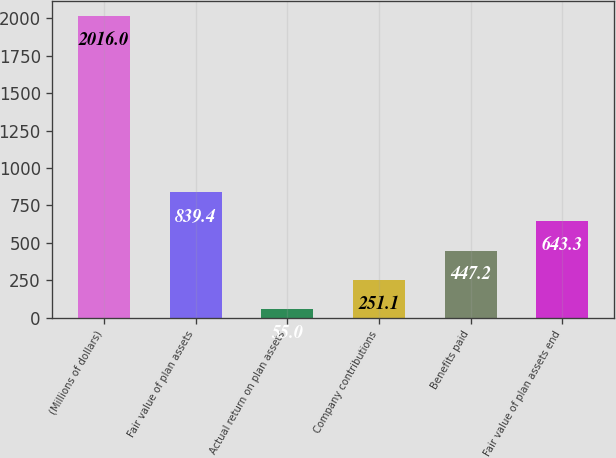Convert chart to OTSL. <chart><loc_0><loc_0><loc_500><loc_500><bar_chart><fcel>(Millions of dollars)<fcel>Fair value of plan assets<fcel>Actual return on plan assets<fcel>Company contributions<fcel>Benefits paid<fcel>Fair value of plan assets end<nl><fcel>2016<fcel>839.4<fcel>55<fcel>251.1<fcel>447.2<fcel>643.3<nl></chart> 